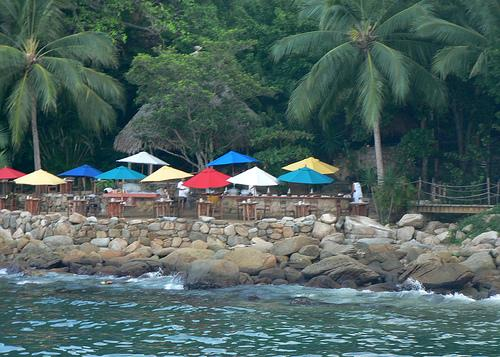What are the trees with one thin trunk called? Please explain your reasoning. palm trees. The trees are seen by the water. 